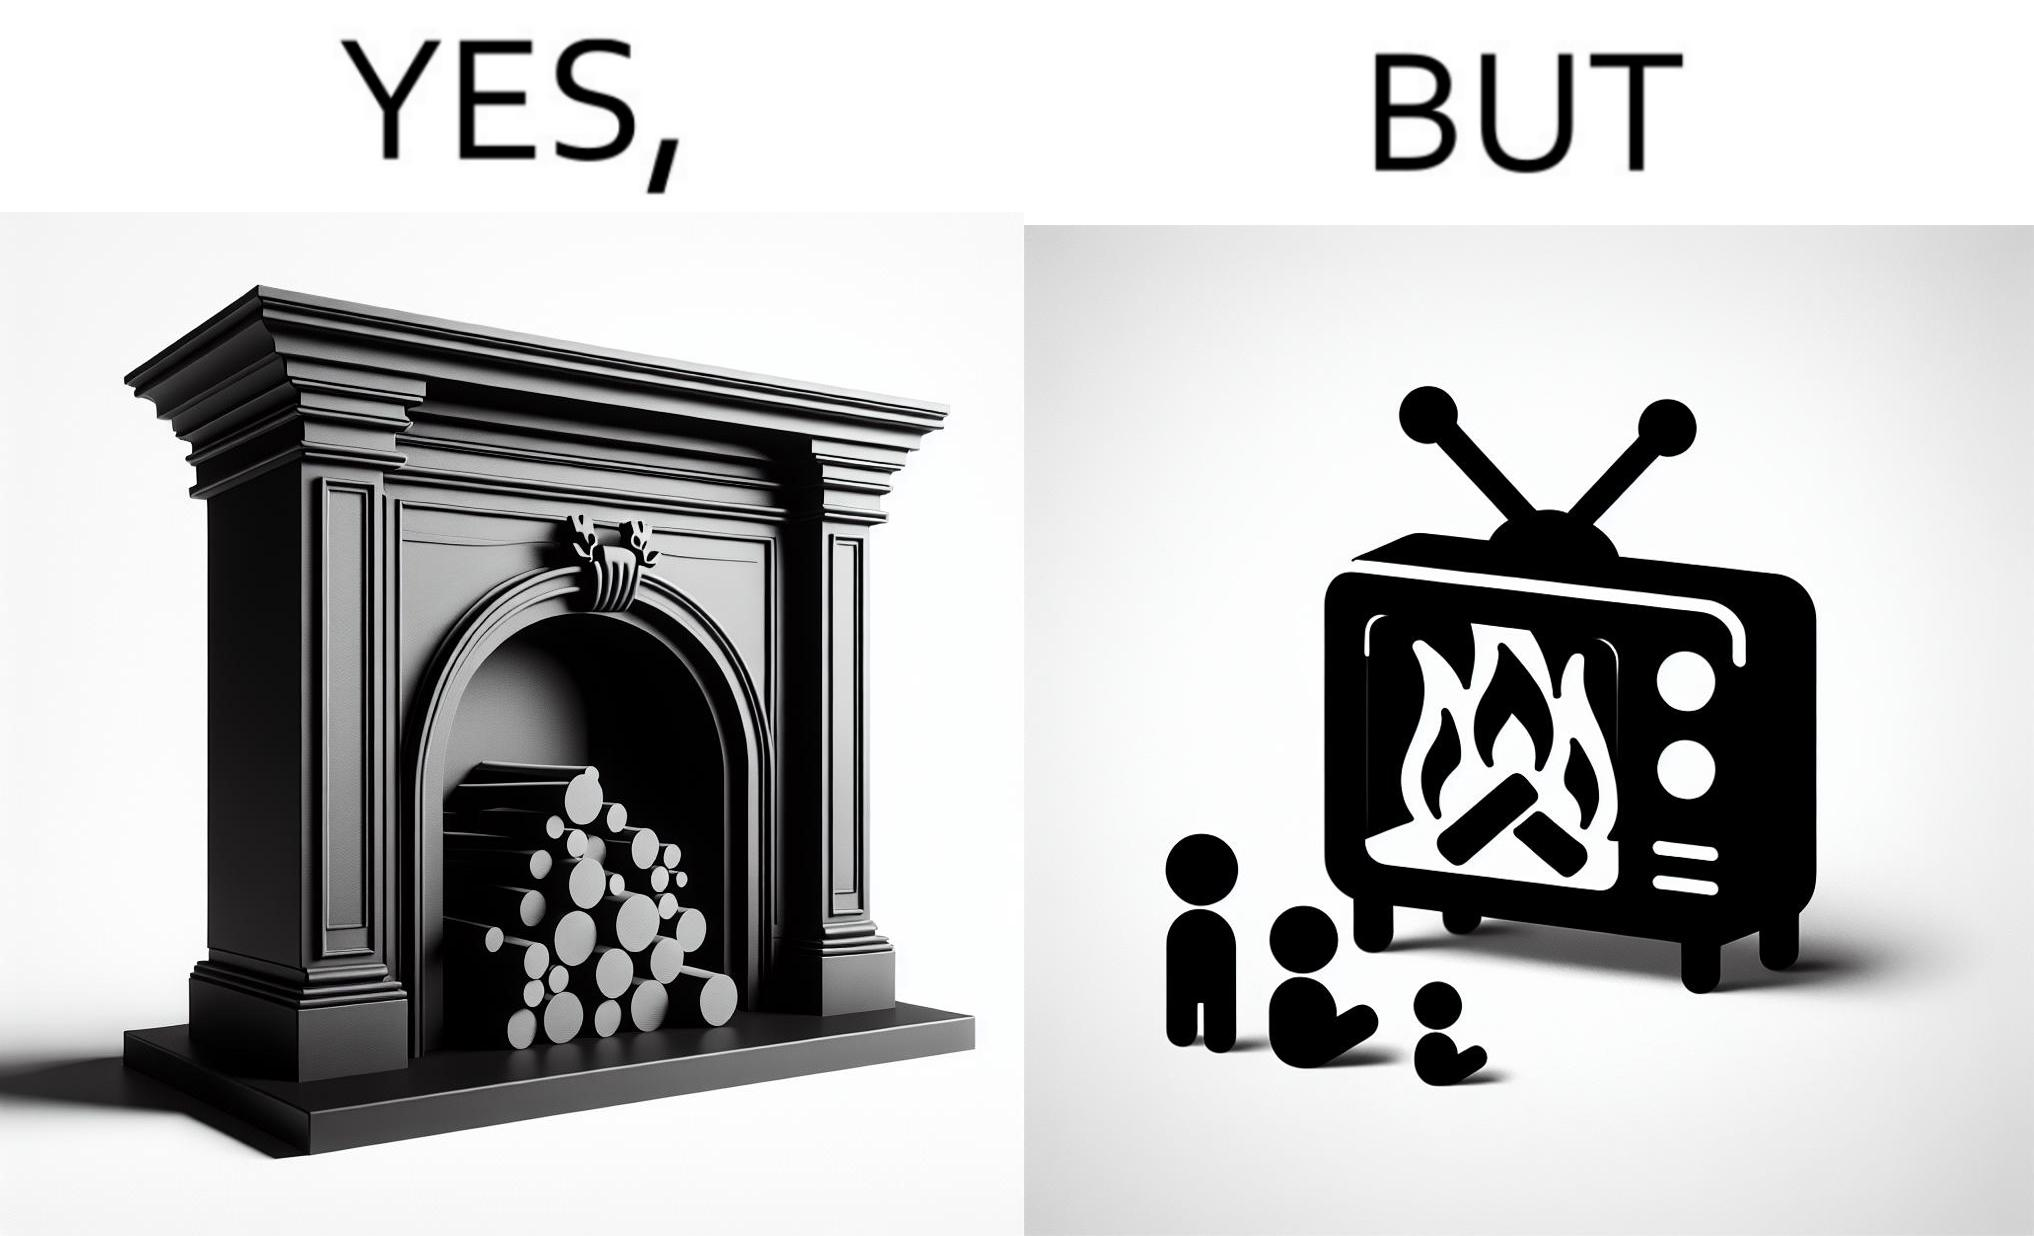Does this image contain satire or humor? Yes, this image is satirical. 